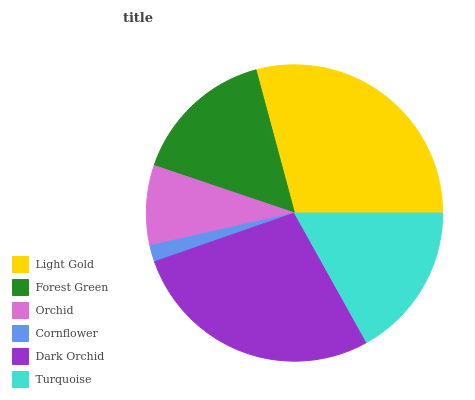Is Cornflower the minimum?
Answer yes or no. Yes. Is Light Gold the maximum?
Answer yes or no. Yes. Is Forest Green the minimum?
Answer yes or no. No. Is Forest Green the maximum?
Answer yes or no. No. Is Light Gold greater than Forest Green?
Answer yes or no. Yes. Is Forest Green less than Light Gold?
Answer yes or no. Yes. Is Forest Green greater than Light Gold?
Answer yes or no. No. Is Light Gold less than Forest Green?
Answer yes or no. No. Is Turquoise the high median?
Answer yes or no. Yes. Is Forest Green the low median?
Answer yes or no. Yes. Is Orchid the high median?
Answer yes or no. No. Is Orchid the low median?
Answer yes or no. No. 